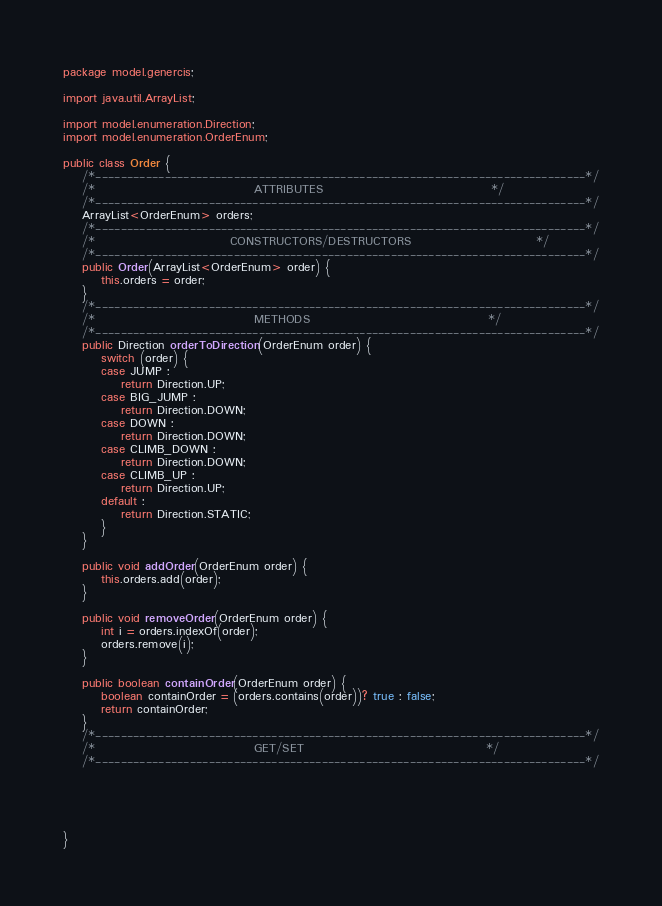Convert code to text. <code><loc_0><loc_0><loc_500><loc_500><_Java_>package model.genercis;

import java.util.ArrayList;

import model.enumeration.Direction;
import model.enumeration.OrderEnum;

public class Order {
	/*------------------------------------------------------------------------------*/
	/*                                 ATTRIBUTES                                   */
	/*------------------------------------------------------------------------------*/
	ArrayList<OrderEnum> orders;
	/*------------------------------------------------------------------------------*/
	/*                            CONSTRUCTORS/DESTRUCTORS                          */
	/*------------------------------------------------------------------------------*/
	public Order(ArrayList<OrderEnum> order) {
		this.orders = order;
	}
	/*------------------------------------------------------------------------------*/
	/*                                 METHODS                                     */
	/*------------------------------------------------------------------------------*/
	public Direction orderToDirection(OrderEnum order) {
		switch (order) {
		case JUMP :
			return Direction.UP;
		case BIG_JUMP :
			return Direction.DOWN;
		case DOWN :
			return Direction.DOWN;
		case CLIMB_DOWN :
			return Direction.DOWN;
		case CLIMB_UP :
			return Direction.UP;
		default :
			return Direction.STATIC;
		}
	}

	public void addOrder(OrderEnum order) {
		this.orders.add(order);
	}
	
	public void removeOrder(OrderEnum order) {
		int i = orders.indexOf(order);
		orders.remove(i);
	}
	
	public boolean containOrder(OrderEnum order) {
		boolean containOrder = (orders.contains(order))? true : false;
		return containOrder;
	}
	/*------------------------------------------------------------------------------*/
	/*                                 GET/SET                                      */
	/*------------------------------------------------------------------------------*/





}
</code> 